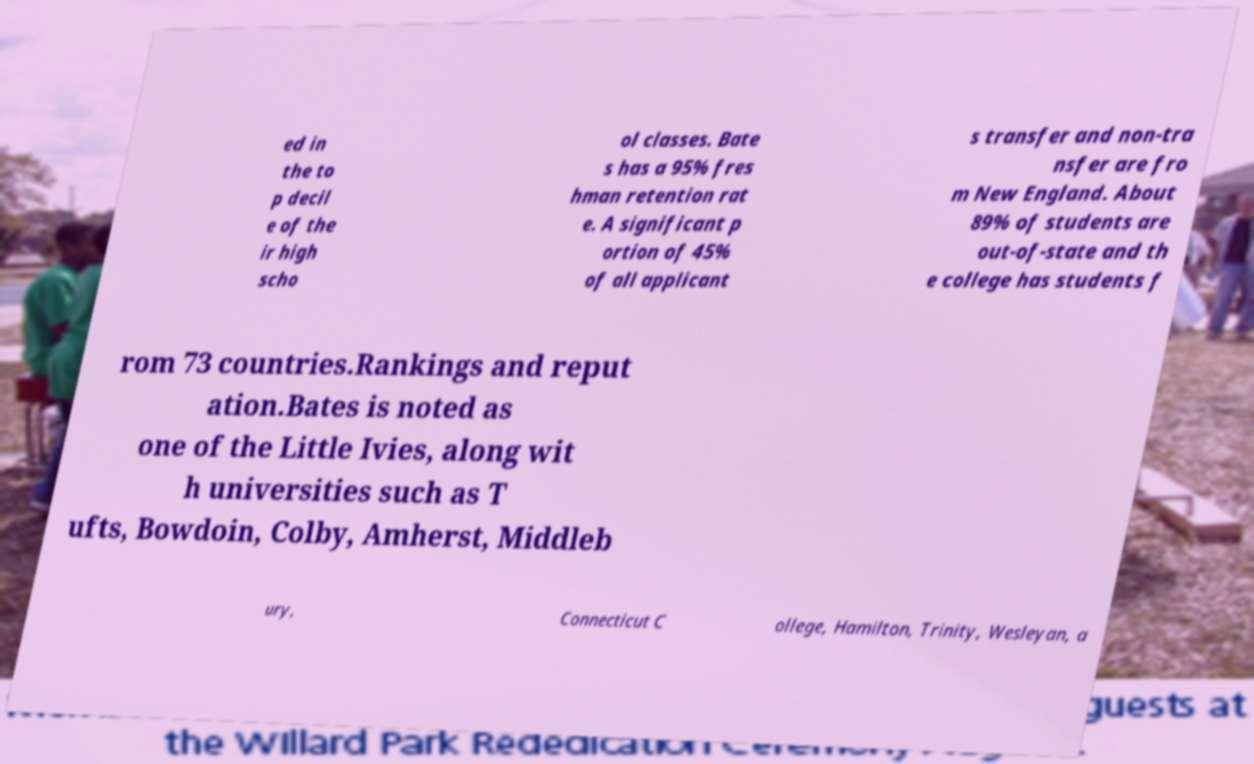Could you extract and type out the text from this image? ed in the to p decil e of the ir high scho ol classes. Bate s has a 95% fres hman retention rat e. A significant p ortion of 45% of all applicant s transfer and non-tra nsfer are fro m New England. About 89% of students are out-of-state and th e college has students f rom 73 countries.Rankings and reput ation.Bates is noted as one of the Little Ivies, along wit h universities such as T ufts, Bowdoin, Colby, Amherst, Middleb ury, Connecticut C ollege, Hamilton, Trinity, Wesleyan, a 